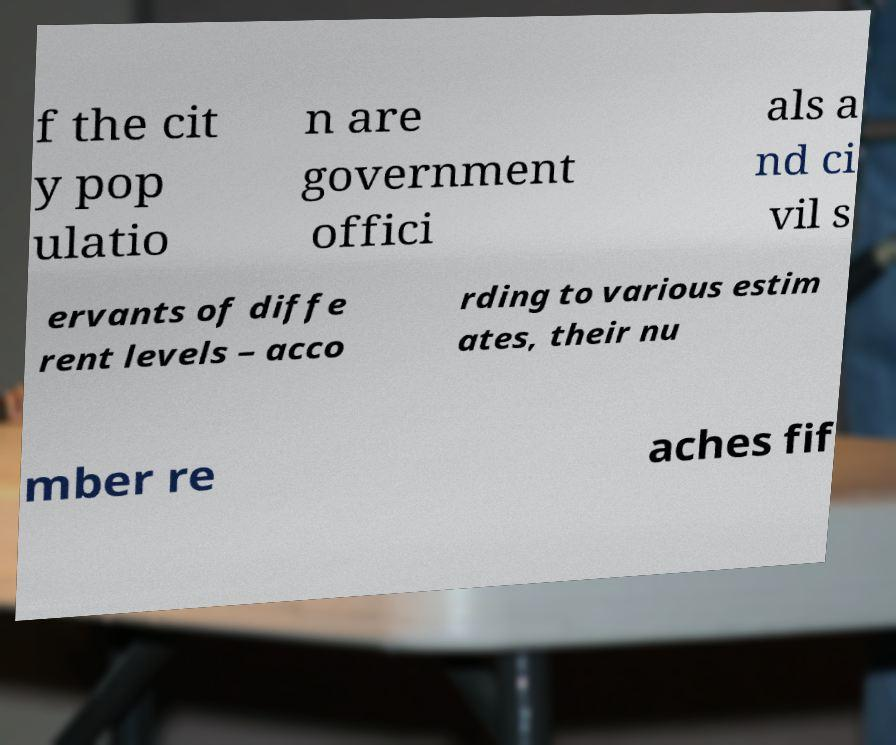Could you assist in decoding the text presented in this image and type it out clearly? f the cit y pop ulatio n are government offici als a nd ci vil s ervants of diffe rent levels – acco rding to various estim ates, their nu mber re aches fif 